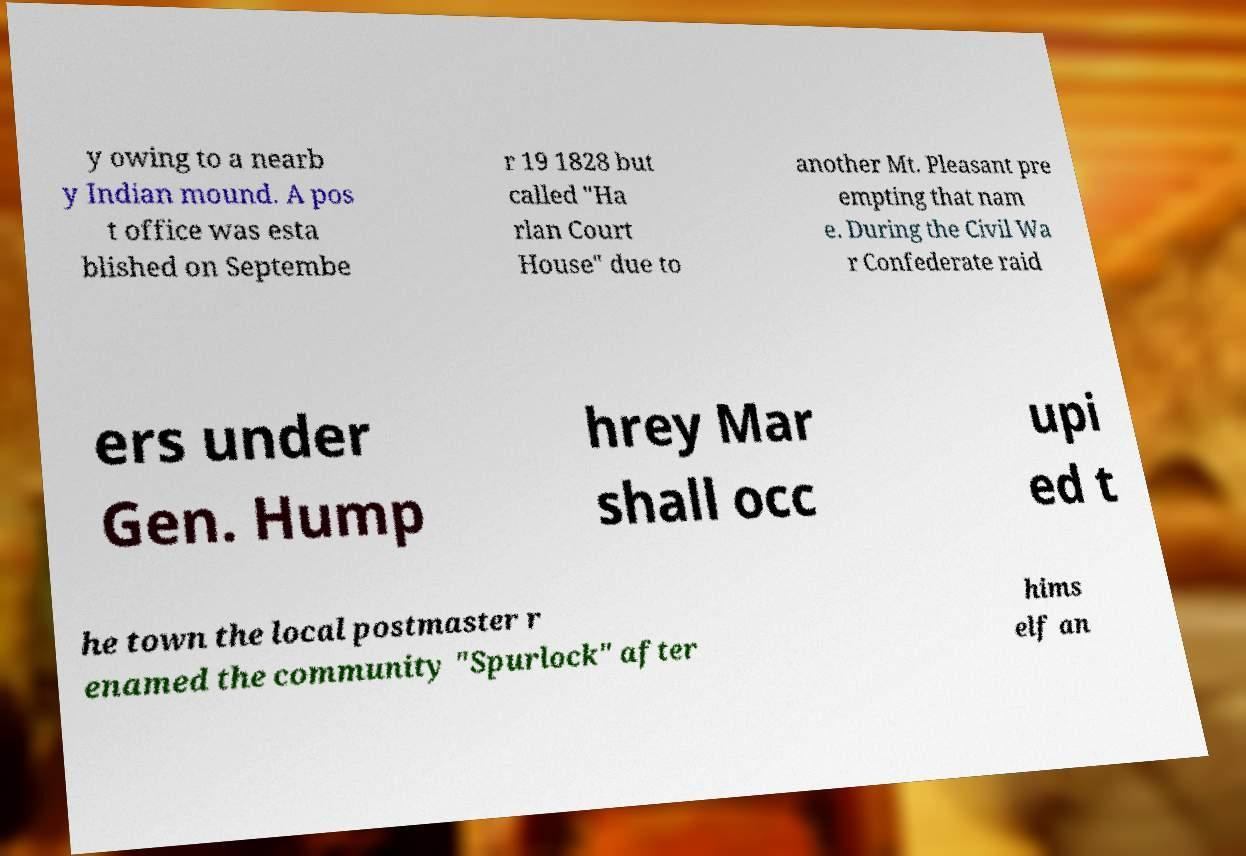Can you accurately transcribe the text from the provided image for me? y owing to a nearb y Indian mound. A pos t office was esta blished on Septembe r 19 1828 but called "Ha rlan Court House" due to another Mt. Pleasant pre empting that nam e. During the Civil Wa r Confederate raid ers under Gen. Hump hrey Mar shall occ upi ed t he town the local postmaster r enamed the community "Spurlock" after hims elf an 